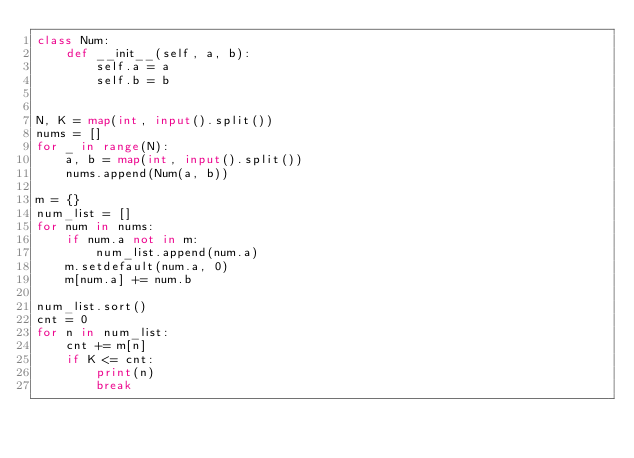Convert code to text. <code><loc_0><loc_0><loc_500><loc_500><_Python_>class Num:
    def __init__(self, a, b):
        self.a = a
        self.b = b


N, K = map(int, input().split())
nums = []
for _ in range(N):
    a, b = map(int, input().split())
    nums.append(Num(a, b))

m = {}
num_list = []
for num in nums:
    if num.a not in m:
        num_list.append(num.a)
    m.setdefault(num.a, 0)
    m[num.a] += num.b

num_list.sort()
cnt = 0
for n in num_list:
    cnt += m[n]
    if K <= cnt:
        print(n)
        break
</code> 